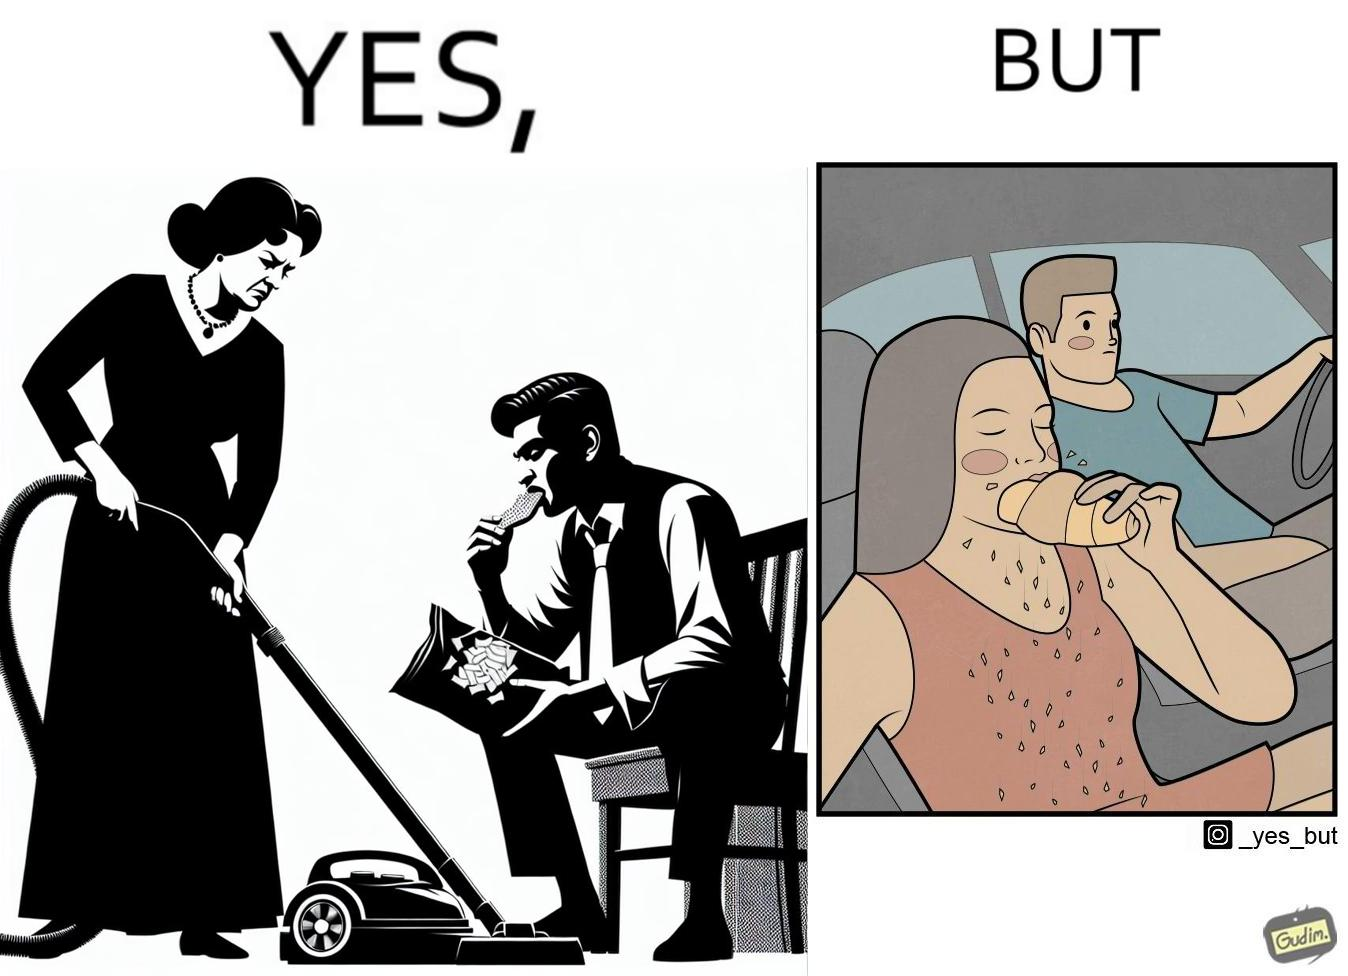Does this image contain satire or humor? Yes, this image is satirical. 